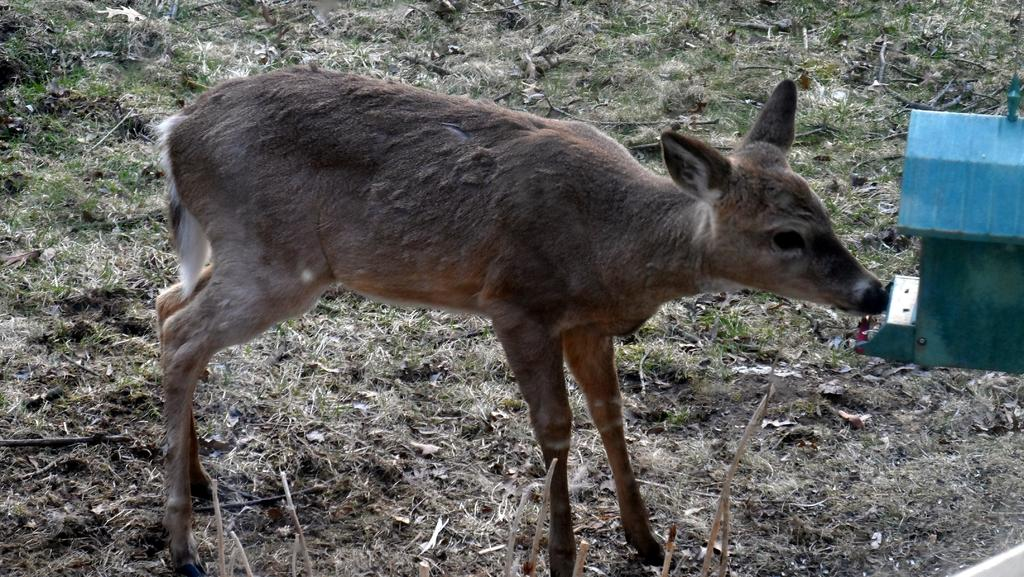What animal can be seen in the picture? There is a deer in the picture. Where is the deer located in the image? The deer is on the floor. What type of vegetation is present in the picture? There is grass in the picture. What industry is the deer associated with in the image? There is no indication of any industry in the image, as it features a deer on the floor with grass in the background. 